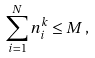Convert formula to latex. <formula><loc_0><loc_0><loc_500><loc_500>\sum _ { i = 1 } ^ { N } n _ { i } ^ { k } \leq M \, ,</formula> 